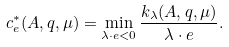Convert formula to latex. <formula><loc_0><loc_0><loc_500><loc_500>c ^ { * } _ { e } ( A , q , \mu ) = \min _ { \lambda \cdot e < 0 } \frac { k _ { \lambda } ( A , q , \mu ) } { \lambda \cdot e } .</formula> 